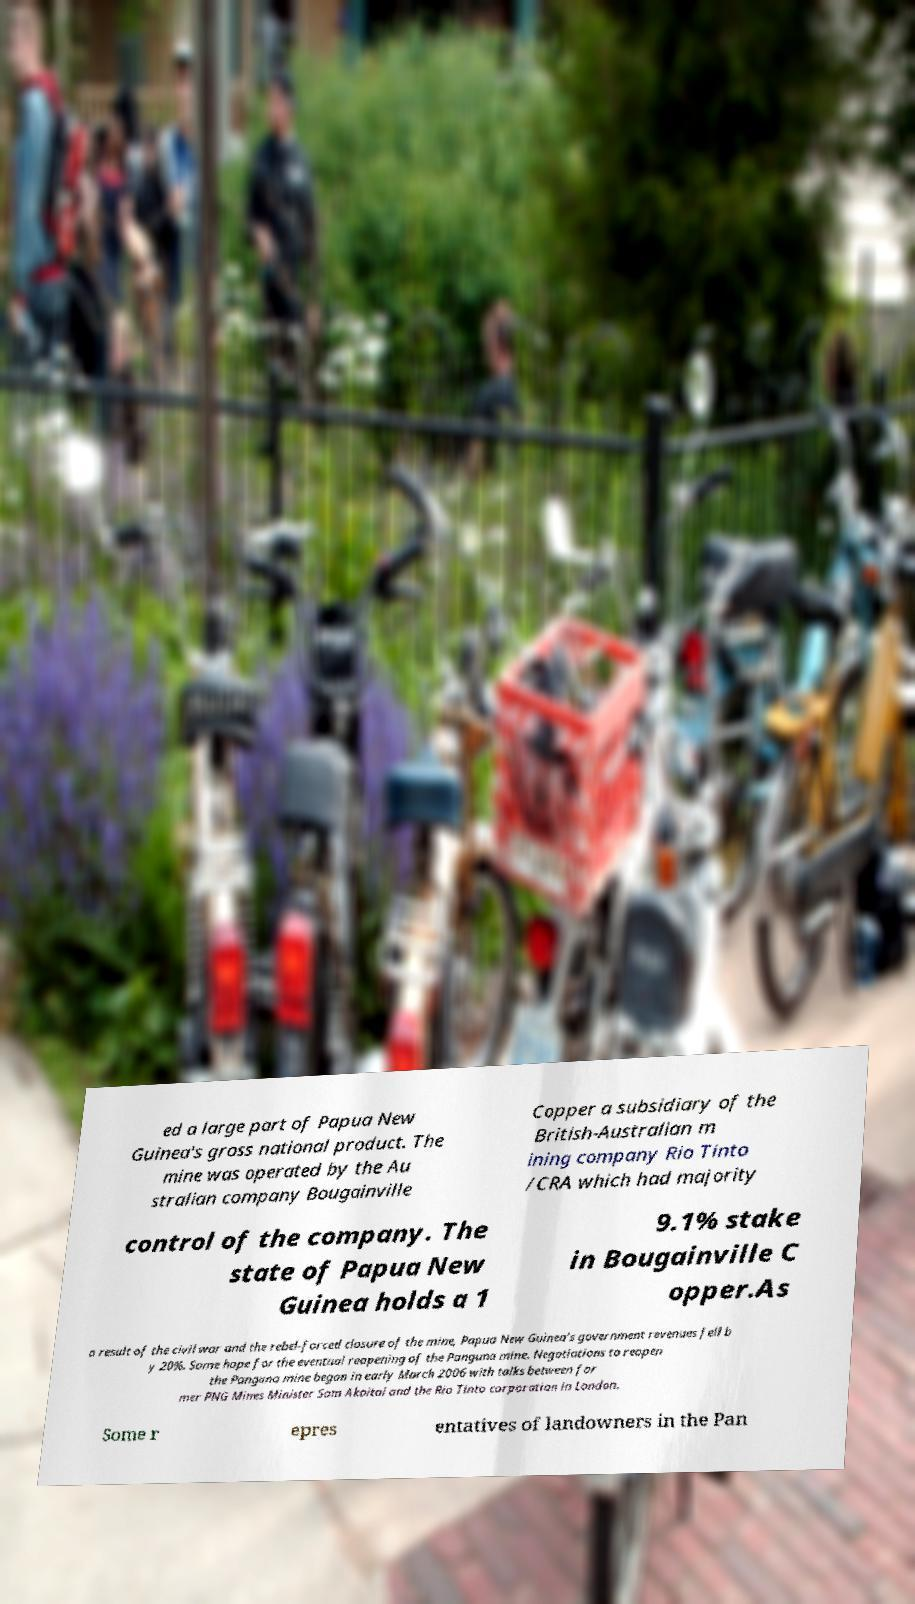What messages or text are displayed in this image? I need them in a readable, typed format. ed a large part of Papua New Guinea's gross national product. The mine was operated by the Au stralian company Bougainville Copper a subsidiary of the British-Australian m ining company Rio Tinto /CRA which had majority control of the company. The state of Papua New Guinea holds a 1 9.1% stake in Bougainville C opper.As a result of the civil war and the rebel-forced closure of the mine, Papua New Guinea's government revenues fell b y 20%. Some hope for the eventual reopening of the Panguna mine. Negotiations to reopen the Panguna mine began in early March 2006 with talks between for mer PNG Mines Minister Sam Akoitai and the Rio Tinto corporation in London. Some r epres entatives of landowners in the Pan 